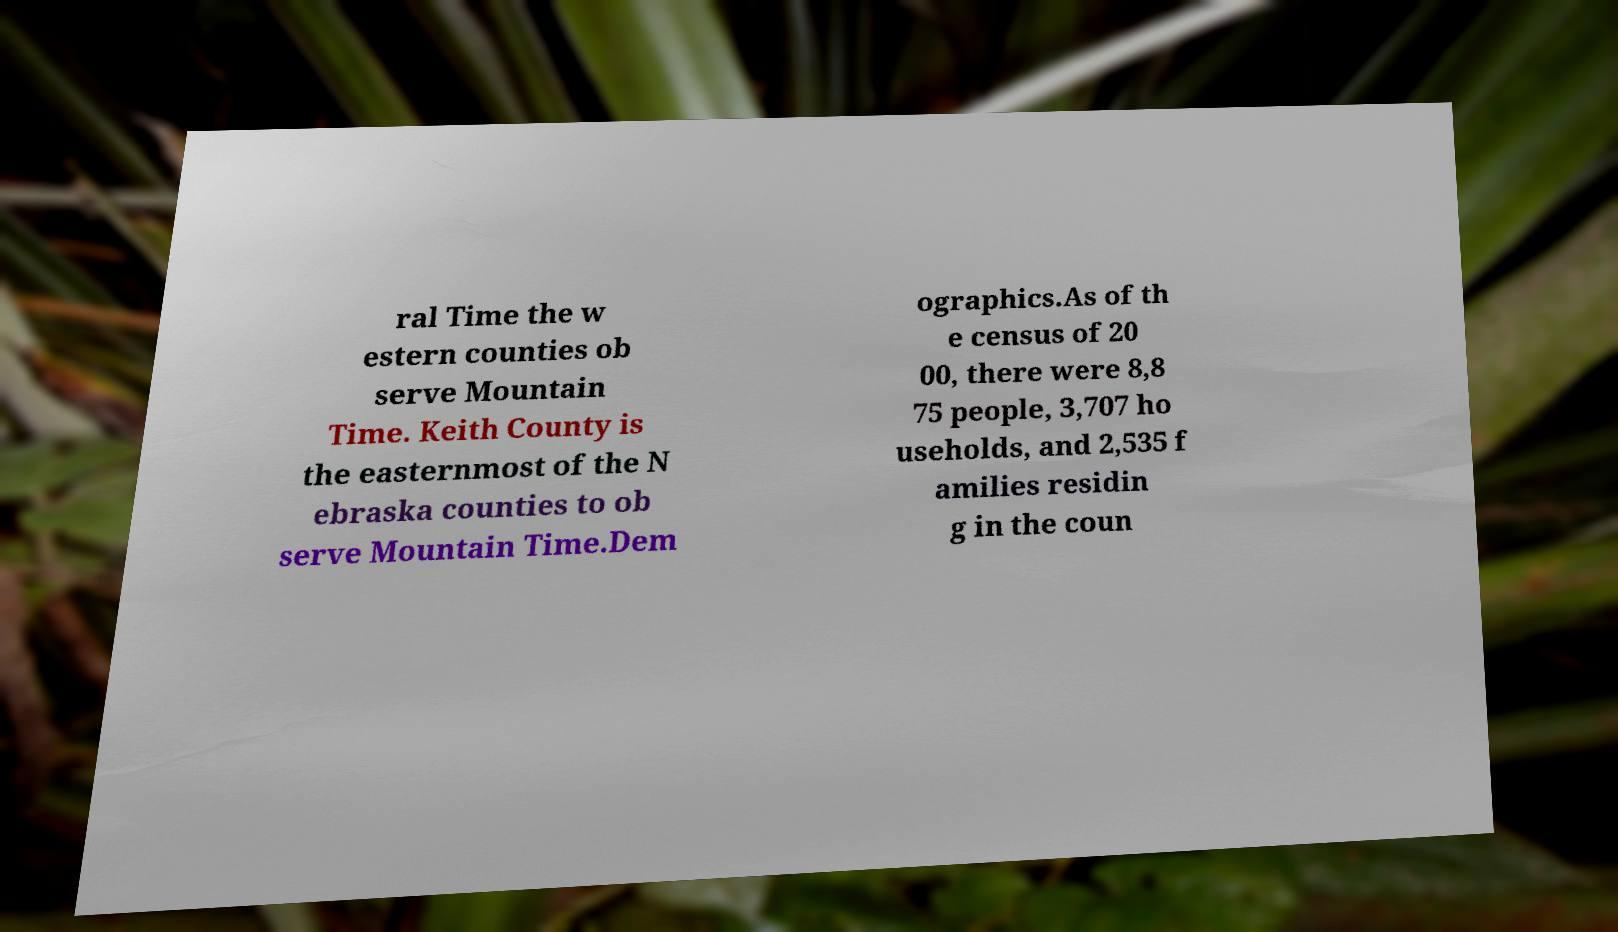There's text embedded in this image that I need extracted. Can you transcribe it verbatim? ral Time the w estern counties ob serve Mountain Time. Keith County is the easternmost of the N ebraska counties to ob serve Mountain Time.Dem ographics.As of th e census of 20 00, there were 8,8 75 people, 3,707 ho useholds, and 2,535 f amilies residin g in the coun 